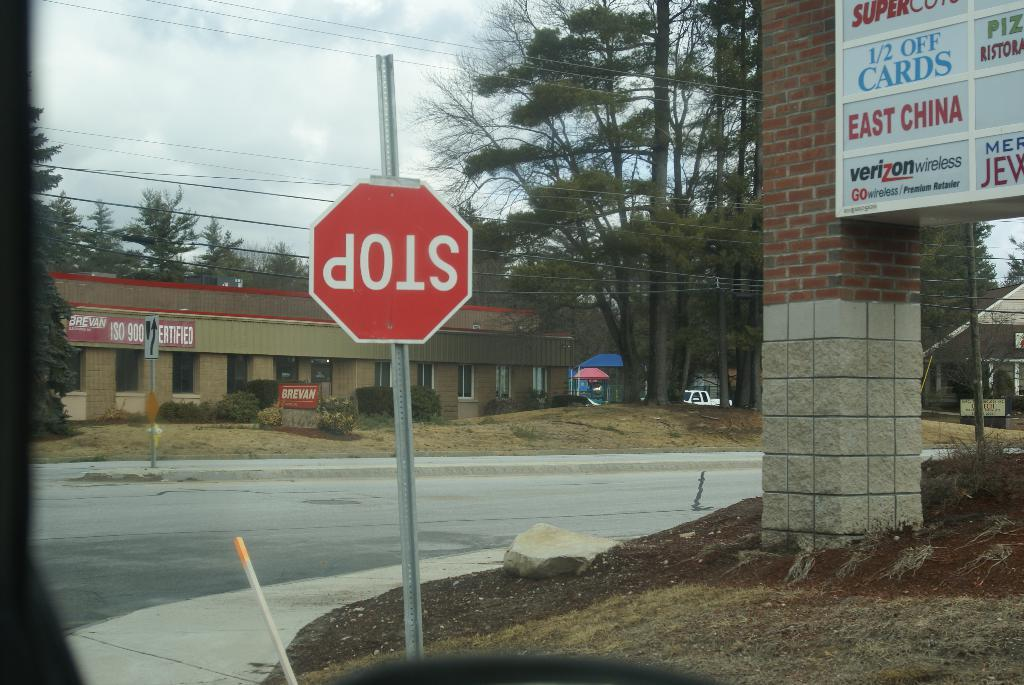<image>
Share a concise interpretation of the image provided. An upside down stop sign on a street corner near a billboard for a shopping center with places such as a Supercuts and a Verizon wireless center. 